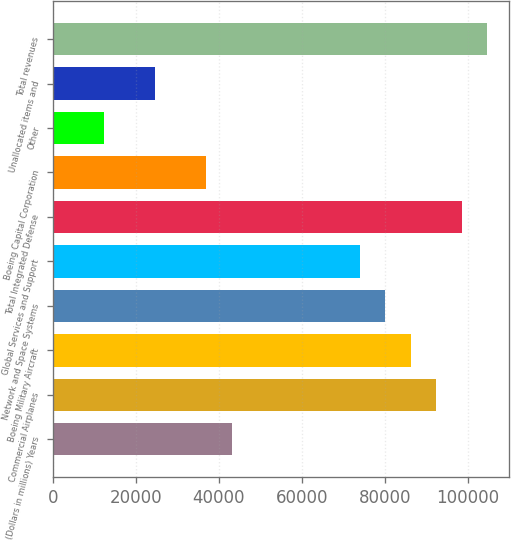<chart> <loc_0><loc_0><loc_500><loc_500><bar_chart><fcel>(Dollars in millions) Years<fcel>Commercial Airplanes<fcel>Boeing Military Aircraft<fcel>Network and Space Systems<fcel>Global Services and Support<fcel>Total Integrated Defense<fcel>Boeing Capital Corporation<fcel>Other<fcel>Unallocated items and<fcel>Total revenues<nl><fcel>43073.7<fcel>92290.5<fcel>86138.4<fcel>79986.3<fcel>73834.2<fcel>98442.6<fcel>36921.6<fcel>12313.2<fcel>24617.4<fcel>104595<nl></chart> 